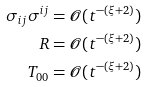Convert formula to latex. <formula><loc_0><loc_0><loc_500><loc_500>\sigma _ { i j } \sigma ^ { i j } & = \mathcal { O } ( t ^ { - ( \xi + 2 ) } ) \\ R & = \mathcal { O } ( t ^ { - ( \xi + 2 ) } ) \\ T _ { 0 0 } & = \mathcal { O } ( t ^ { - ( \xi + 2 ) } )</formula> 